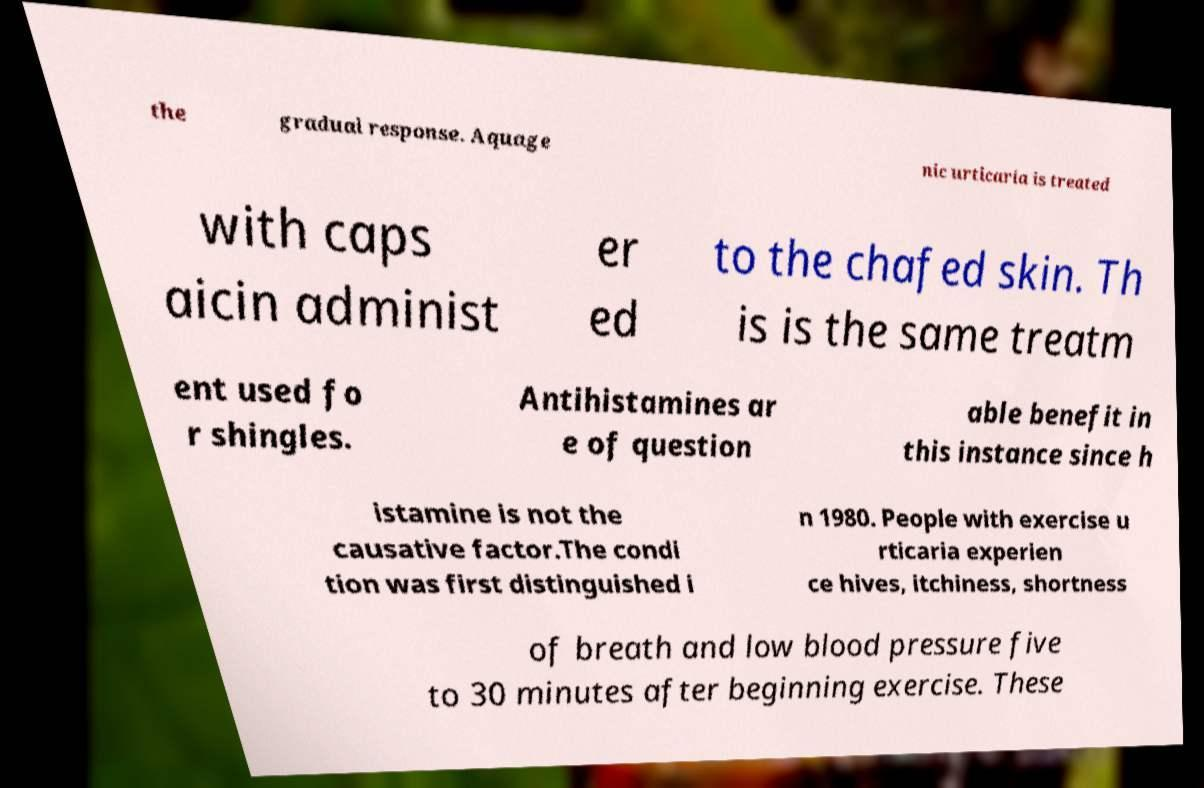Can you accurately transcribe the text from the provided image for me? the gradual response. Aquage nic urticaria is treated with caps aicin administ er ed to the chafed skin. Th is is the same treatm ent used fo r shingles. Antihistamines ar e of question able benefit in this instance since h istamine is not the causative factor.The condi tion was first distinguished i n 1980. People with exercise u rticaria experien ce hives, itchiness, shortness of breath and low blood pressure five to 30 minutes after beginning exercise. These 